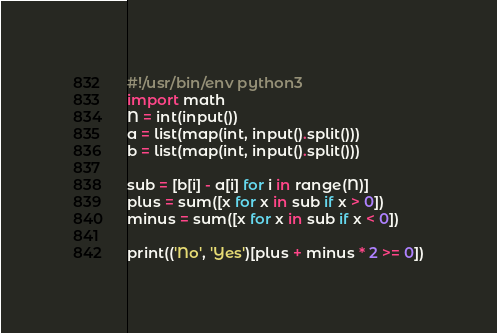Convert code to text. <code><loc_0><loc_0><loc_500><loc_500><_Python_>#!/usr/bin/env python3
import math
N = int(input())
a = list(map(int, input().split()))
b = list(map(int, input().split()))

sub = [b[i] - a[i] for i in range(N)]
plus = sum([x for x in sub if x > 0])
minus = sum([x for x in sub if x < 0])

print(('No', 'Yes')[plus + minus * 2 >= 0])
</code> 